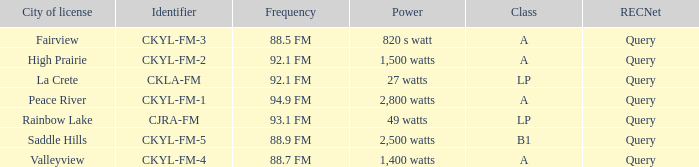What is the city of license that has a 1,400 watts power Valleyview. 